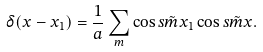Convert formula to latex. <formula><loc_0><loc_0><loc_500><loc_500>\delta ( x - x _ { 1 } ) = \frac { 1 } { a } \sum _ { m } \cos s { \tilde { m } } { x _ { 1 } } \cos s { \tilde { m } } { x } .</formula> 